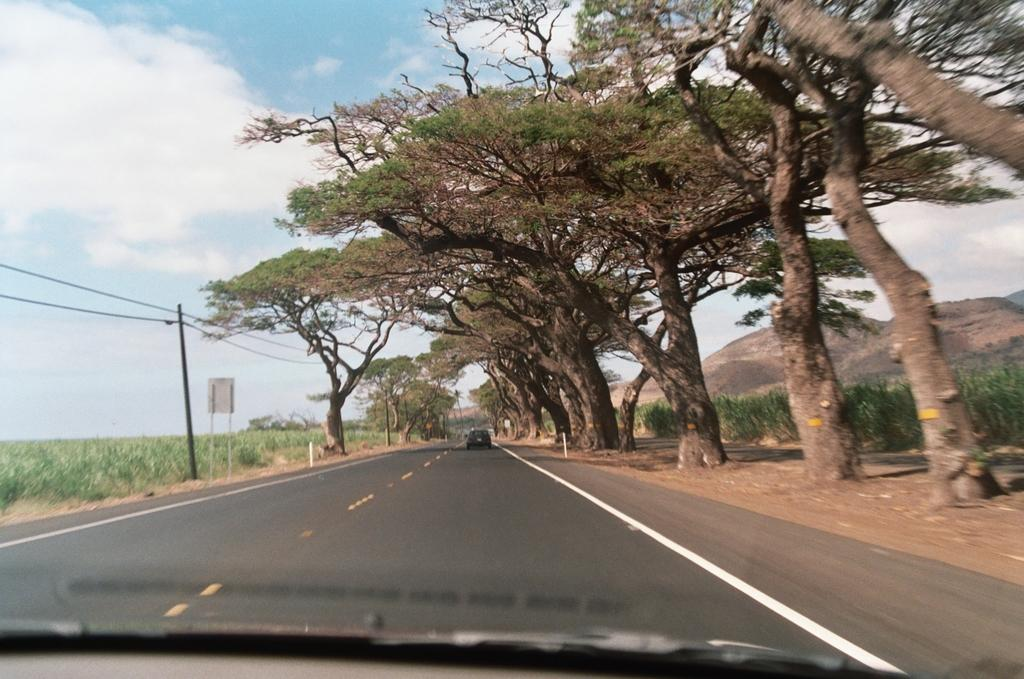What can be seen on the road in the image? There are vehicles on the road in the image. What type of vegetation is present in the image? There is a group of trees and plants in the image. What is the purpose of the board in the image? The question is unclear. Please provide more context or information about the board. What is attached to the utility pole in the image? There are wires attached to the utility pole in the image. What type of landscape can be seen in the image? The hills are visible in the image. What is the condition of the sky in the image? The sky is visible in the image, and it looks cloudy. How many people are trying to escape from the jail in the image? There is no jail present in the image. Can you describe the cap that the person is wearing in the image? There are no people or caps visible in the image. 